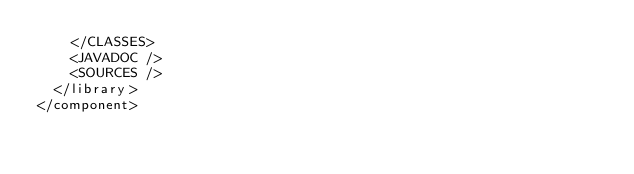Convert code to text. <code><loc_0><loc_0><loc_500><loc_500><_XML_>    </CLASSES>
    <JAVADOC />
    <SOURCES />
  </library>
</component></code> 